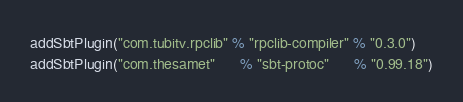Convert code to text. <code><loc_0><loc_0><loc_500><loc_500><_Scala_>addSbtPlugin("com.tubitv.rpclib" % "rpclib-compiler" % "0.3.0")
addSbtPlugin("com.thesamet"      % "sbt-protoc"      % "0.99.18")
</code> 